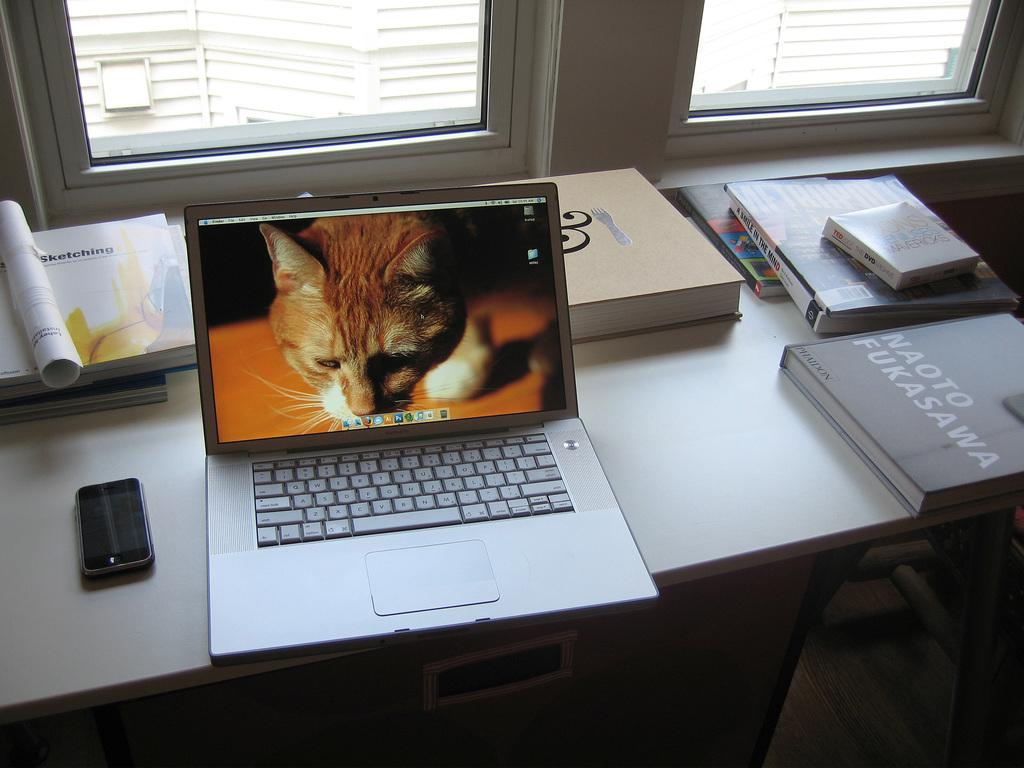What piece of furniture is present in the image? There is a table in the image. How many windows can be seen in the image? There are two windows in the image. What can be seen outside the windows? Buildings are visible outside the windows. What electronic devices are on the table? There is a laptop and a mobile on the table. What else is on the table besides electronic devices? There are books and a box on the table. What type of pump is used to generate the theory in the image? There is no pump or theory present in the image. Can you see any cows outside the windows in the image? There are no cows visible outside the windows in the image; only buildings can be seen. 